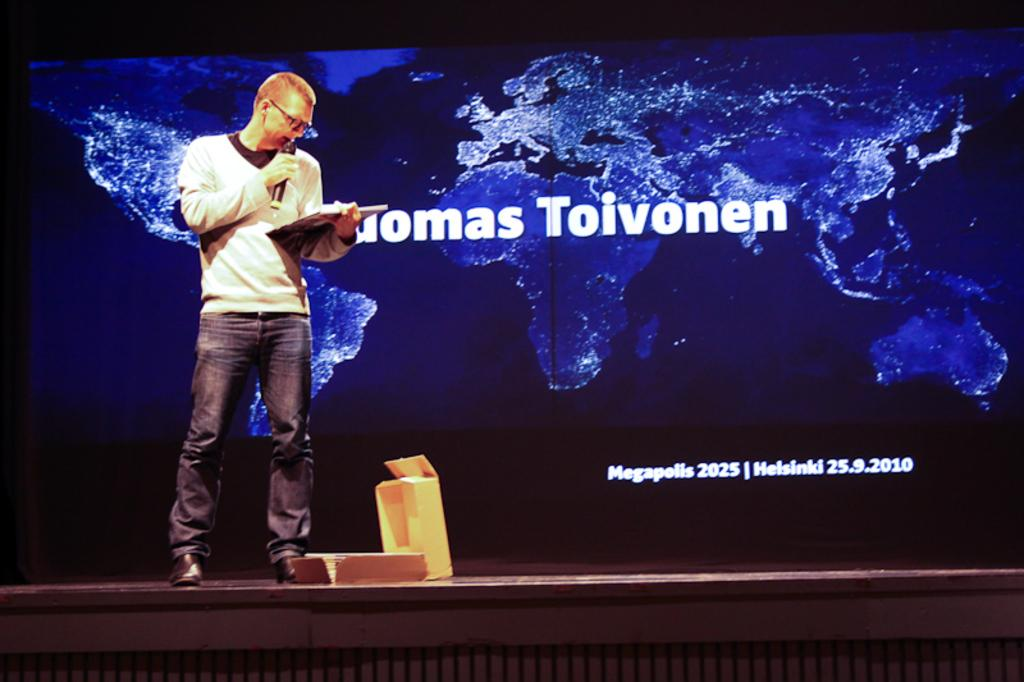<image>
Provide a brief description of the given image. A man holding a microphone and clipboard stands on a stage before a backround that says Thomas Toivonen over a map of the world. 